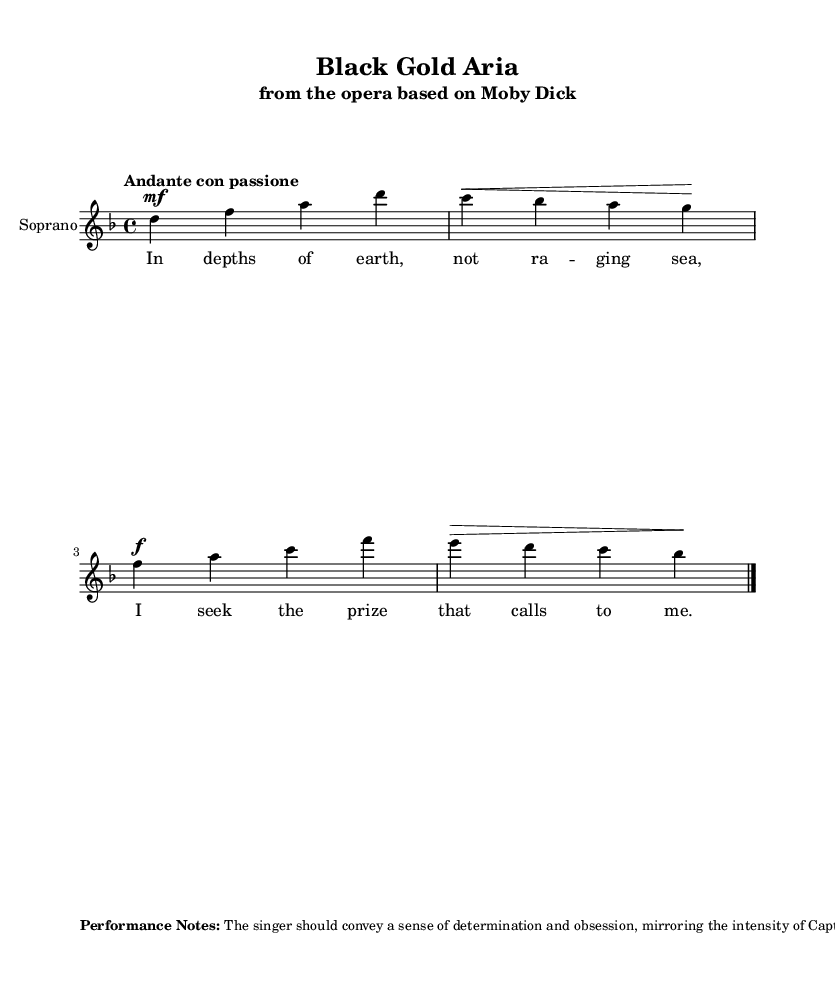What is the key signature of this music? The key signature shown in the music indicates D minor, which has one flat (B flat) and is indicated at the beginning of the staff.
Answer: D minor What is the time signature of this piece? The time signature is found in the beginning of the staff, displaying four beats per measure, which is represented as 4/4.
Answer: 4/4 What is the tempo marking for this aria? The tempo marking "Andante con passione" appears above the staff, indicating the speed and manner in which the music should be played.
Answer: Andante con passione What is the primary theme discussed in the lyrics? The lyrics suggest a focus on oil exploration, contrasting it with whaling, which is a clue to the thematic content that involves searching for resources in the earth.
Answer: Oil exploration How should the singer convey emotion according to the performance notes? The performance notes suggest that the singer should express a sense of determination and obsession, paralleling Captain Ahab’s quest but emphasizing oil exploration instead.
Answer: Determination and obsession How many measures are in this excerpt? The music excerpt contains four measures, which is visually confirmed by counting the distinct bar lines present in the notation.
Answer: Four measures 